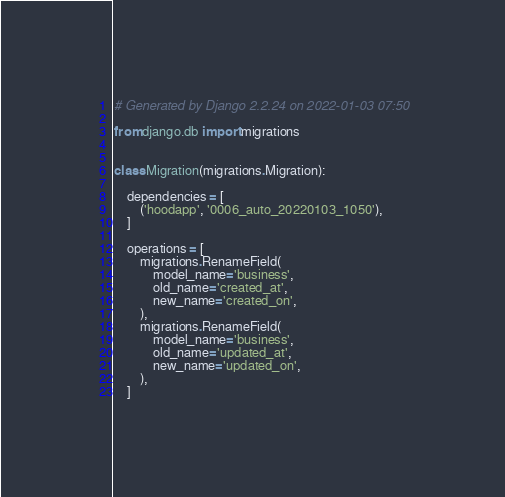Convert code to text. <code><loc_0><loc_0><loc_500><loc_500><_Python_># Generated by Django 2.2.24 on 2022-01-03 07:50

from django.db import migrations


class Migration(migrations.Migration):

    dependencies = [
        ('hoodapp', '0006_auto_20220103_1050'),
    ]

    operations = [
        migrations.RenameField(
            model_name='business',
            old_name='created_at',
            new_name='created_on',
        ),
        migrations.RenameField(
            model_name='business',
            old_name='updated_at',
            new_name='updated_on',
        ),
    ]
</code> 